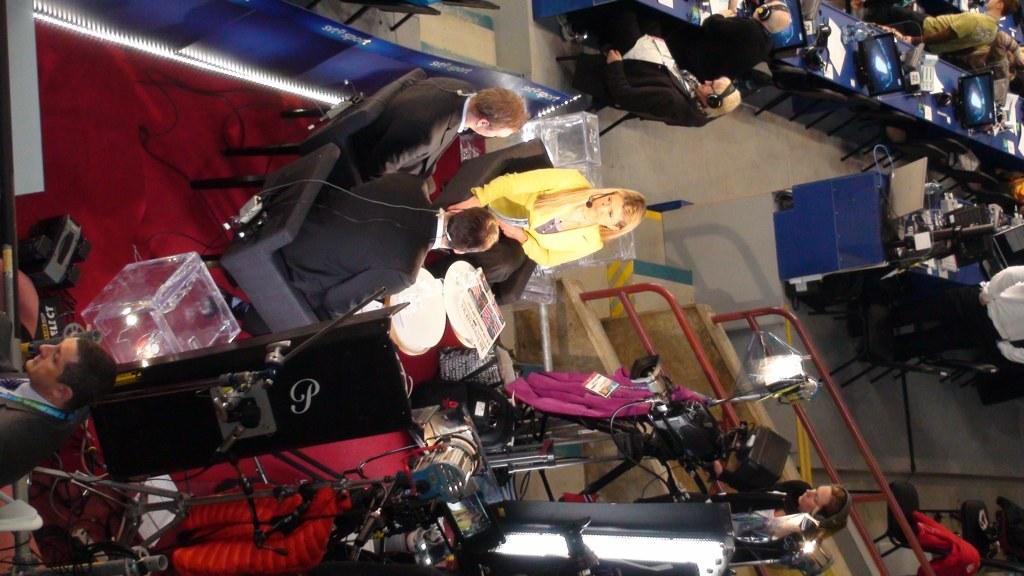Please provide a concise description of this image. In the center of the picture there are people sitting in chairs. On the left there are speakers, boxes, lights, man and other objects. On the right there are tables, desktops, laptop, cables, people, chairs and other objects. At the bottom there are lights, camera, cloth and people. 